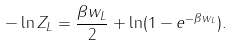Convert formula to latex. <formula><loc_0><loc_0><loc_500><loc_500>- \ln Z _ { L } = { \frac { \beta w _ { L } } { 2 } } + \ln ( 1 - e ^ { - \beta w _ { L } } ) .</formula> 